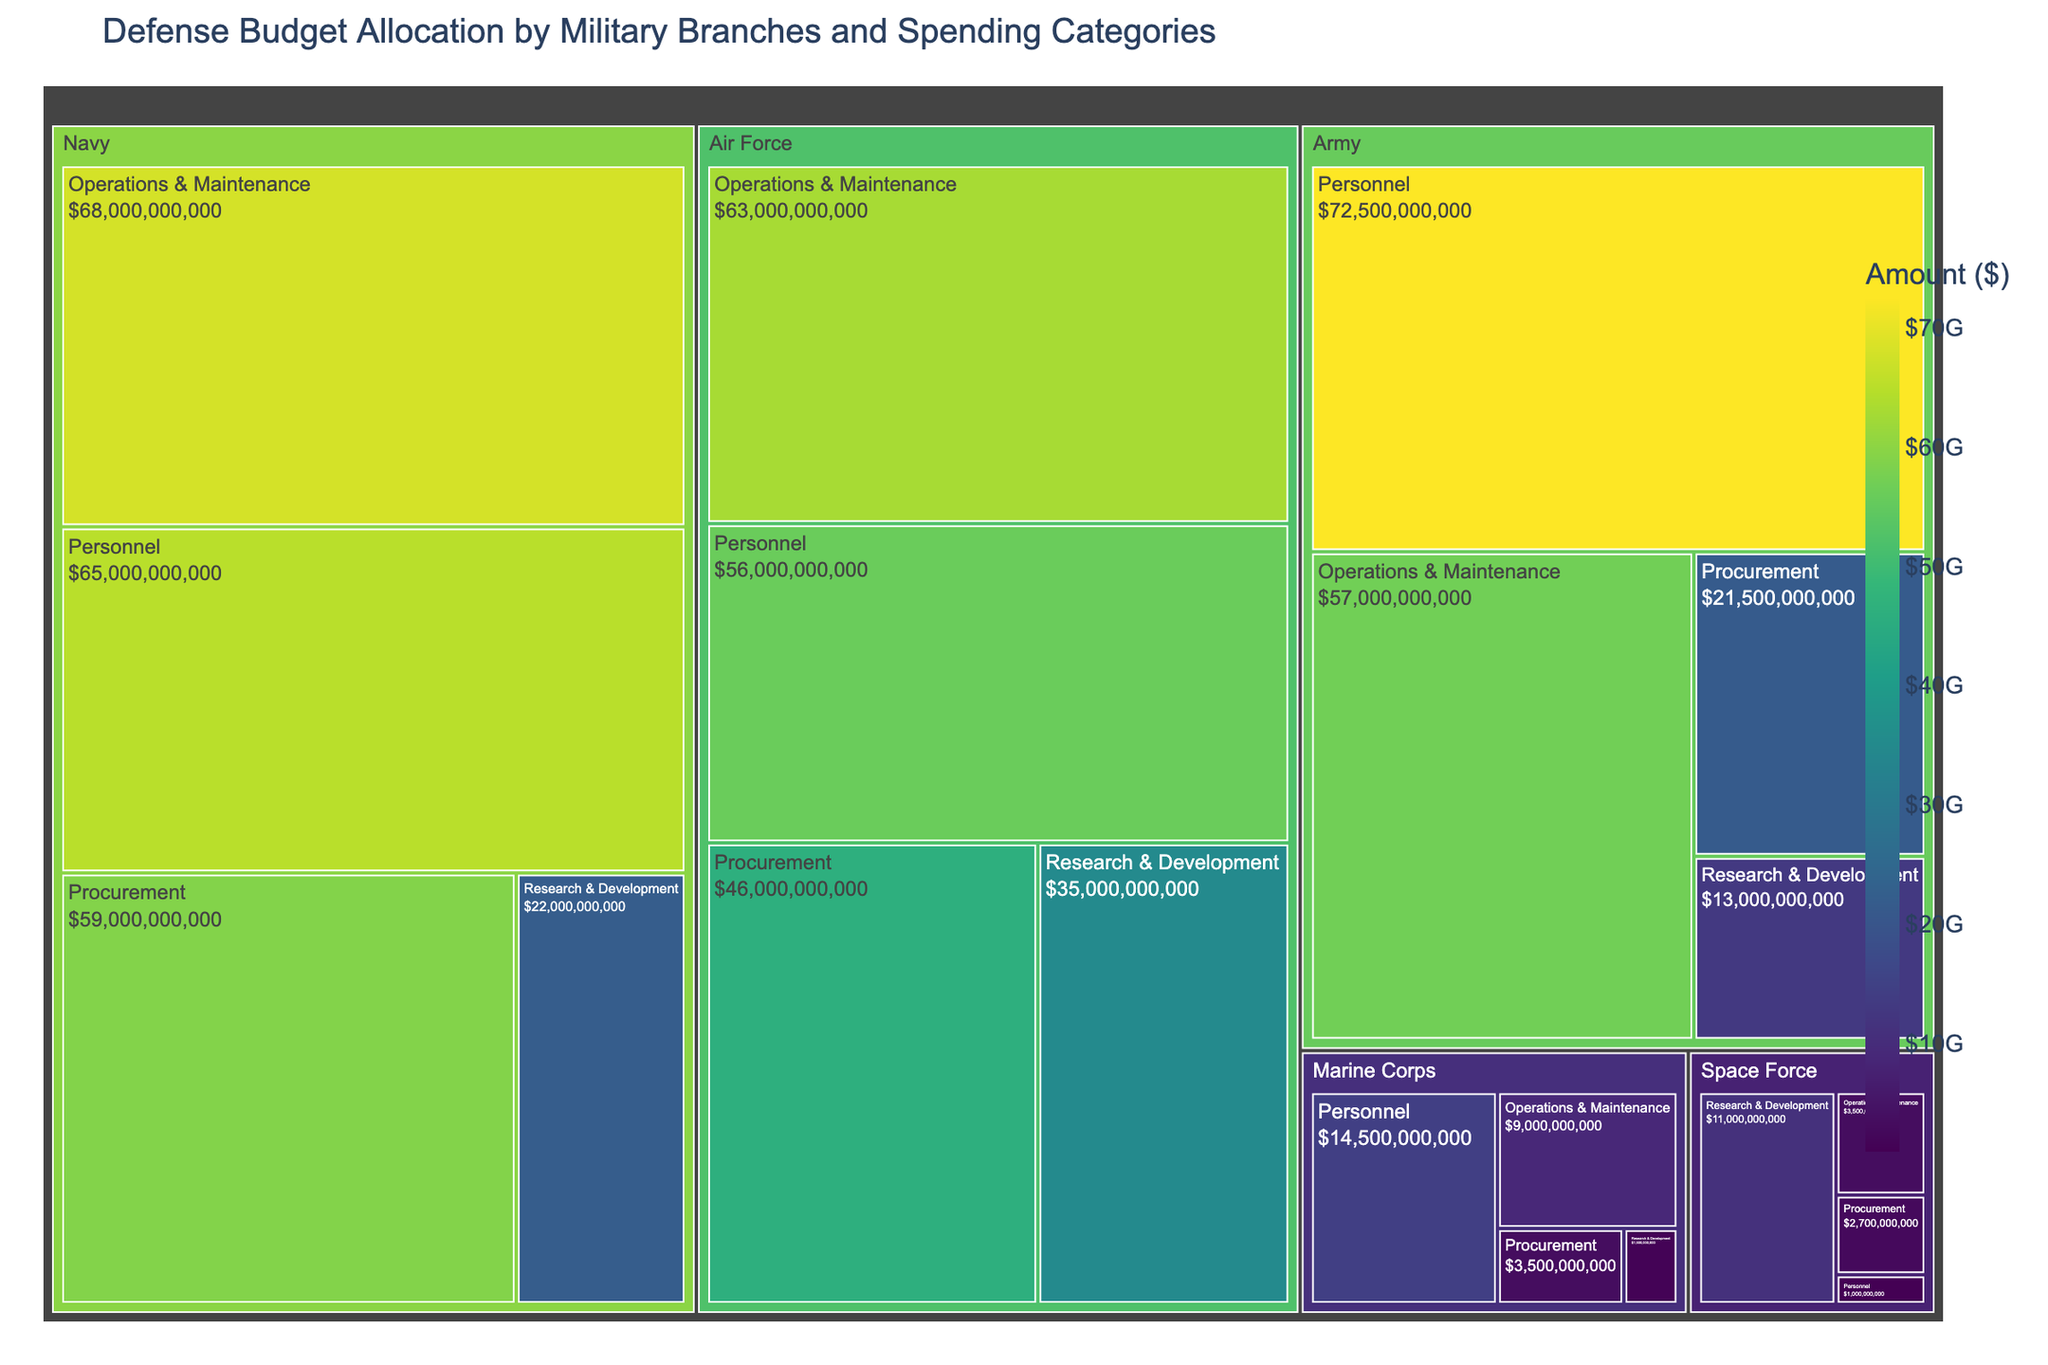What branch has the highest amount allocated to 'Personnel'? The treemap shows the breakdown of budget allocation by military branches and spending categories. The 'Army' branch under the 'Personnel' category has the largest rectangle, indicating the highest amount.
Answer: Army Which branch has the lowest total budget allocation? To find the branch with the lowest total budget allocation, sum up the amounts for each branch. The 'Space Force' has the smallest combined budget across all categories.
Answer: Space Force How does the 'Operations & Maintenance' budget of the Navy compare to that of the Air Force? The 'Navy' has a budget of $68,000,000,000 for 'Operations & Maintenance', while the 'Air Force' has $63,000,000,000. The Navy's budget is higher.
Answer: Navy's budget is higher What is the total budget allocation for the 'Marine Corps'? Sum up all the amounts for the 'Marine Corps' across all categories: $14,500,000,000 (Personnel) + $9,000,000,000 (Operations & Maintenance) + $3,500,000,000 (Procurement) + $1,500,000,000 (Research & Development) = $28,500,000,000.
Answer: $28,500,000,000 Which category has the highest budget in the 'Air Force'? The 'Air Force' breakdown shows 'Operations & Maintenance' has $63,000,000,000, higher than the other categories.
Answer: Operations & Maintenance What is the combined budget for 'Research & Development' across all branches? Sum up 'Research & Development' for all branches: Army ($13,000,000,000) + Navy ($22,000,000,000) + Air Force ($35,000,000,000) + Marine Corps ($1,500,000,000) + Space Force ($11,000,000,000) = $82,500,000,000.
Answer: $82,500,000,000 Compare the 'Procurement' budget allocation between the 'Army' and the 'Navy'. Which one has more? The 'Army' has $21,500,000,000 allocated for 'Procurement', while the 'Navy' has $59,000,000,000. The Navy has a higher 'Procurement' budget.
Answer: Navy What percentage of the 'Army's total budget is allocated to 'Personnel'? The total budget for the 'Army' is $214,500,000,000. The 'Personnel' category is $72,500,000,000. The percentage is ($72,500,000,000 / $214,500,000,000) * 100 = 33.8%.
Answer: 33.8% Which military branch allocates the most to 'Research & Development'? By observing the budget allocations in the treemap, the 'Air Force' has the highest amount allocated to 'Research & Development' at $35,000,000,000.
Answer: Air Force 